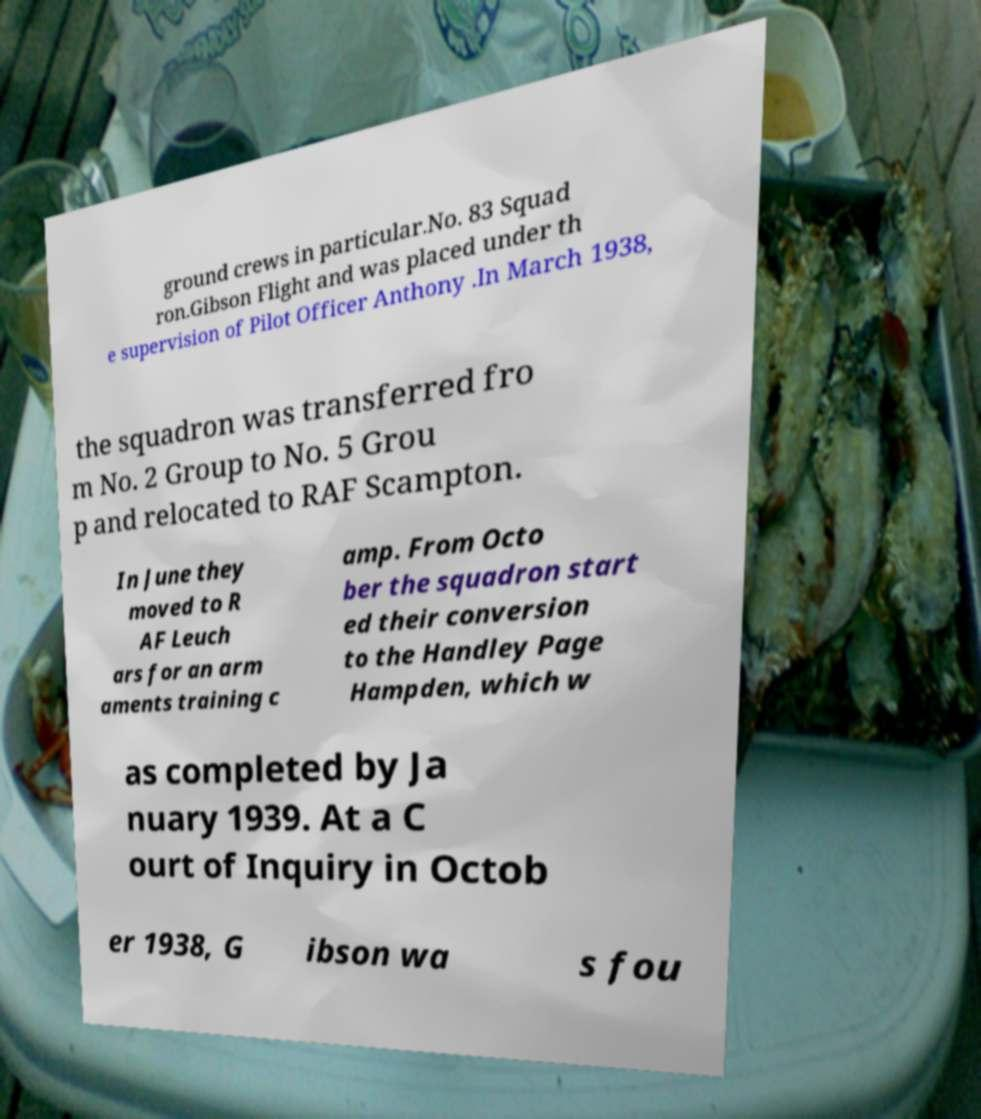There's text embedded in this image that I need extracted. Can you transcribe it verbatim? ground crews in particular.No. 83 Squad ron.Gibson Flight and was placed under th e supervision of Pilot Officer Anthony .In March 1938, the squadron was transferred fro m No. 2 Group to No. 5 Grou p and relocated to RAF Scampton. In June they moved to R AF Leuch ars for an arm aments training c amp. From Octo ber the squadron start ed their conversion to the Handley Page Hampden, which w as completed by Ja nuary 1939. At a C ourt of Inquiry in Octob er 1938, G ibson wa s fou 